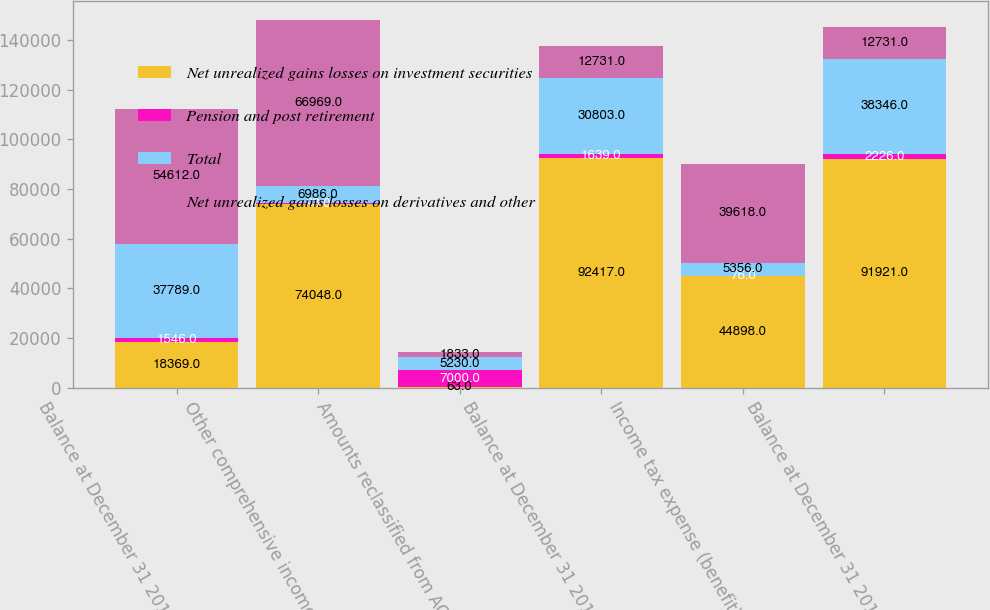<chart> <loc_0><loc_0><loc_500><loc_500><stacked_bar_chart><ecel><fcel>Balance at December 31 2015<fcel>Other comprehensive income<fcel>Amounts reclassified from AOCI<fcel>Balance at December 31 2016<fcel>Income tax expense (benefit)<fcel>Balance at December 31 2014<nl><fcel>Net unrealized gains losses on investment securities<fcel>18369<fcel>74048<fcel>63<fcel>92417<fcel>44898<fcel>91921<nl><fcel>Pension and post retirement<fcel>1546<fcel>93<fcel>7000<fcel>1639<fcel>76<fcel>2226<nl><fcel>Total<fcel>37789<fcel>6986<fcel>5230<fcel>30803<fcel>5356<fcel>38346<nl><fcel>Net unrealized gains losses on derivatives and other<fcel>54612<fcel>66969<fcel>1833<fcel>12731<fcel>39618<fcel>12731<nl></chart> 